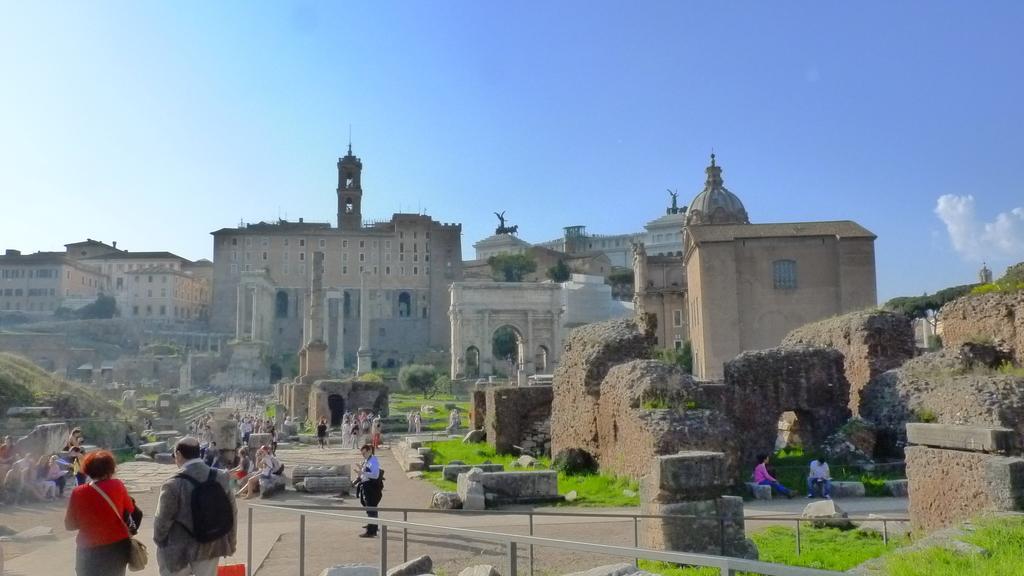How would you summarize this image in a sentence or two? On the left side, there are two persons. Beside them, there is a fence. On the right side, there is grass on the ground and there is a fence. In the background, there are persons, there are buildings, towers and there are clouds in the blue sky. 